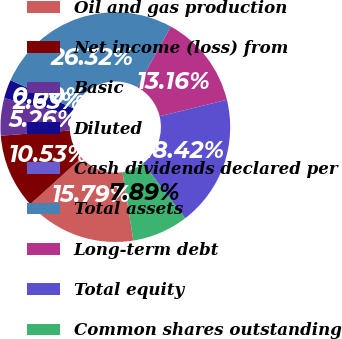Convert chart to OTSL. <chart><loc_0><loc_0><loc_500><loc_500><pie_chart><fcel>Oil and gas production<fcel>Net income (loss) from<fcel>Basic<fcel>Diluted<fcel>Cash dividends declared per<fcel>Total assets<fcel>Long-term debt<fcel>Total equity<fcel>Common shares outstanding<nl><fcel>15.79%<fcel>10.53%<fcel>5.26%<fcel>2.63%<fcel>0.0%<fcel>26.32%<fcel>13.16%<fcel>18.42%<fcel>7.89%<nl></chart> 